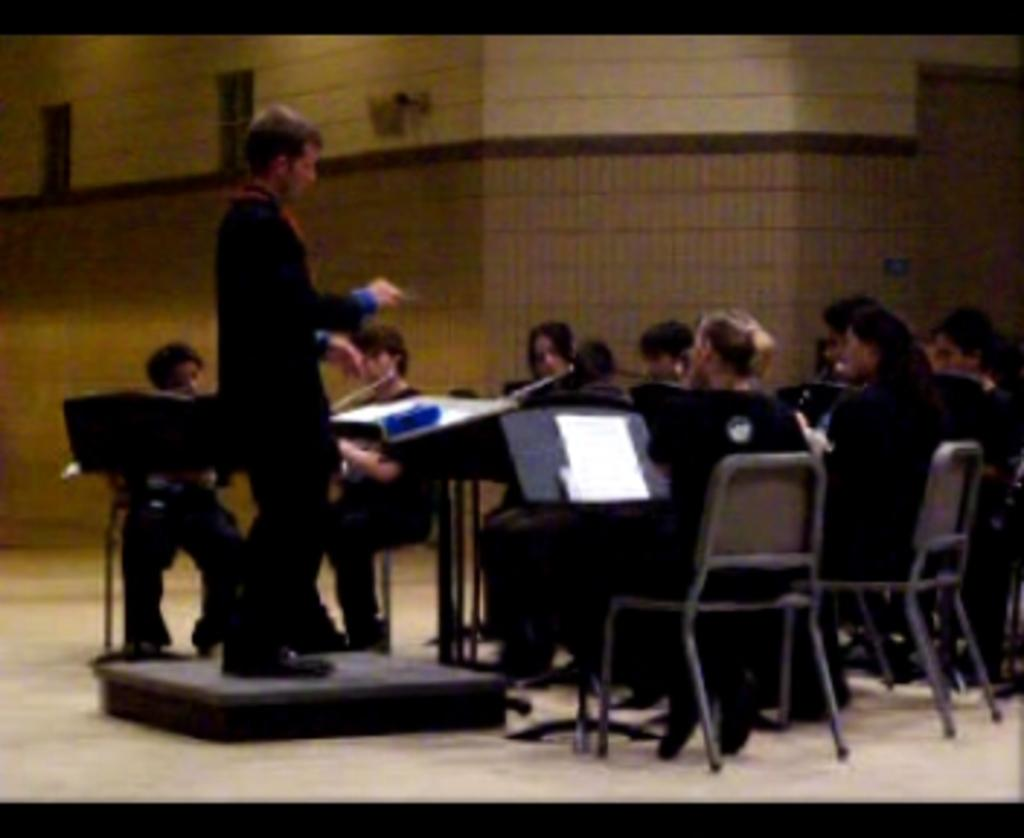What is the main subject of the image? The main subject of the image is a man standing on a dais. What is the man standing on? The man is standing on a dais. What are the other people in the image doing? The other people in the image are sitting in chairs. What can be seen in the background of the image? There is a wall in the background of the image. What songs is the man singing in the image? There is no indication in the image that the man is singing any songs. 